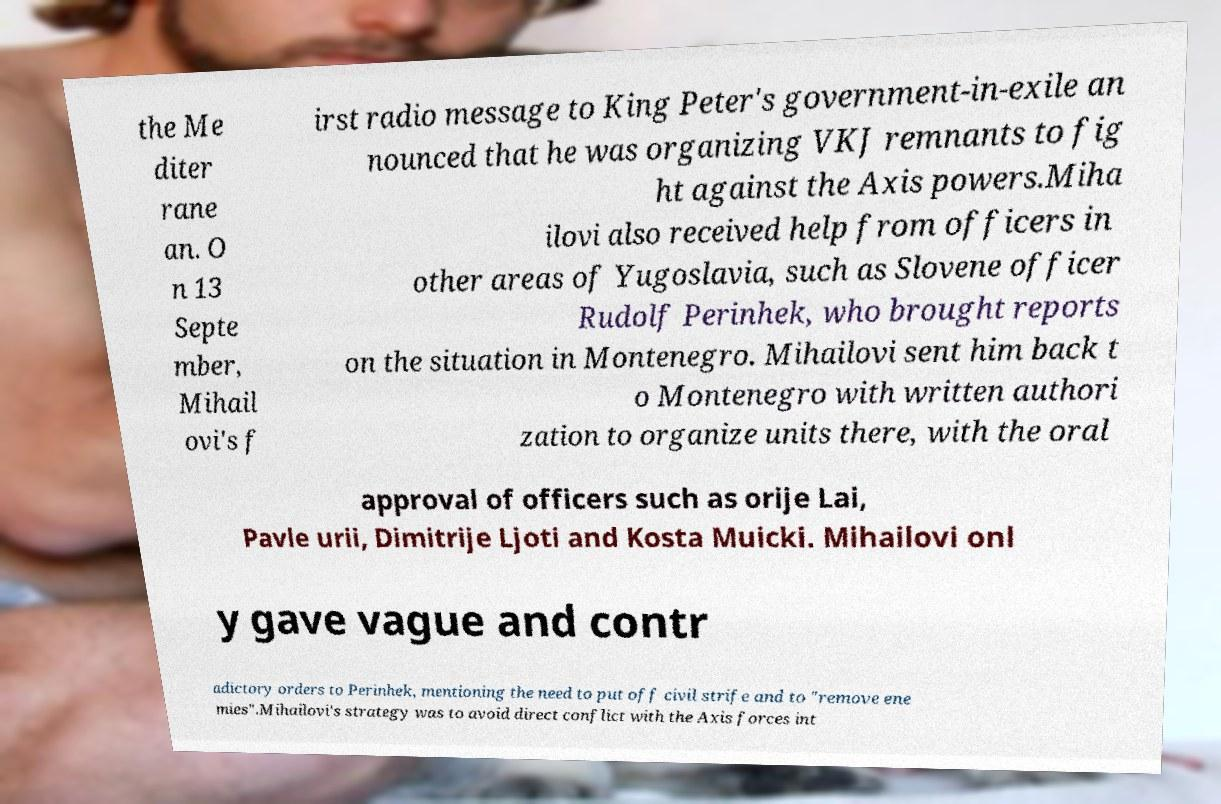Can you read and provide the text displayed in the image?This photo seems to have some interesting text. Can you extract and type it out for me? the Me diter rane an. O n 13 Septe mber, Mihail ovi's f irst radio message to King Peter's government-in-exile an nounced that he was organizing VKJ remnants to fig ht against the Axis powers.Miha ilovi also received help from officers in other areas of Yugoslavia, such as Slovene officer Rudolf Perinhek, who brought reports on the situation in Montenegro. Mihailovi sent him back t o Montenegro with written authori zation to organize units there, with the oral approval of officers such as orije Lai, Pavle urii, Dimitrije Ljoti and Kosta Muicki. Mihailovi onl y gave vague and contr adictory orders to Perinhek, mentioning the need to put off civil strife and to "remove ene mies".Mihailovi's strategy was to avoid direct conflict with the Axis forces int 